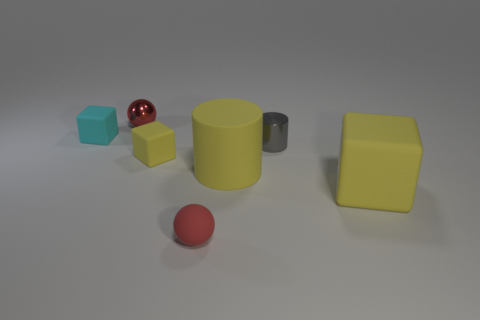Subtract all cyan blocks. How many blocks are left? 2 Add 2 cyan blocks. How many objects exist? 9 Subtract all yellow blocks. How many blocks are left? 1 Subtract 1 cubes. How many cubes are left? 2 Subtract all blue spheres. How many yellow blocks are left? 2 Subtract all cylinders. How many objects are left? 5 Subtract 0 blue cubes. How many objects are left? 7 Subtract all yellow blocks. Subtract all red cylinders. How many blocks are left? 1 Subtract all large yellow objects. Subtract all yellow cubes. How many objects are left? 3 Add 2 cubes. How many cubes are left? 5 